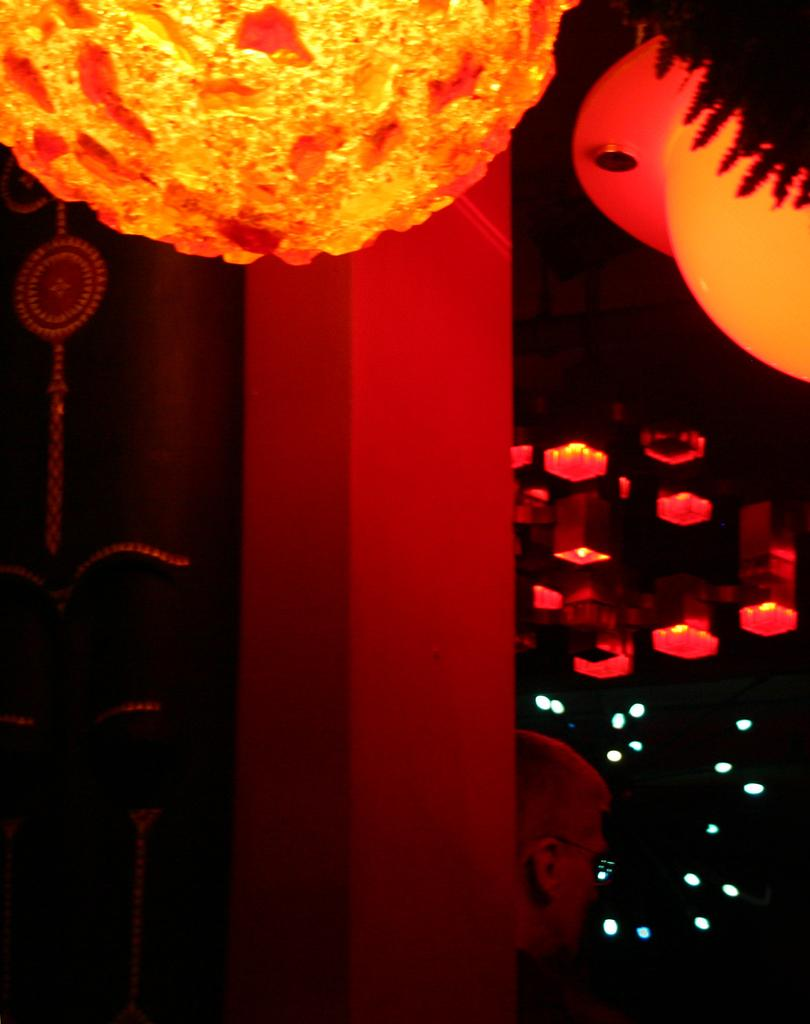Who or what is present in the image? There is a person in the image. What can be seen in the image that provides illumination? There are lights in the image. Can you describe any specific objects on the roof in the image? There are lamps on the roof in the image. What level of education does the person in the image have? There is no information about the person's education in the image. What type of mark can be seen on the lamps on the roof? There are no marks visible on the lamps on the roof in the image. 